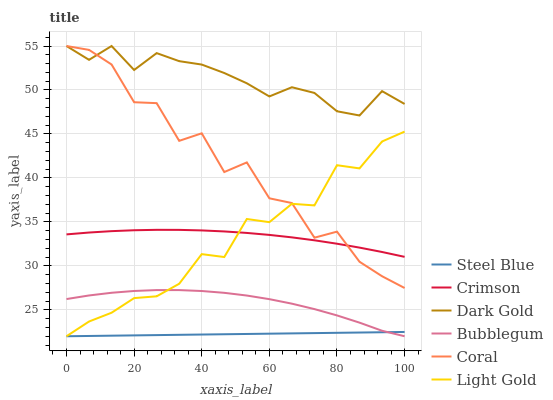Does Coral have the minimum area under the curve?
Answer yes or no. No. Does Coral have the maximum area under the curve?
Answer yes or no. No. Is Coral the smoothest?
Answer yes or no. No. Is Steel Blue the roughest?
Answer yes or no. No. Does Coral have the lowest value?
Answer yes or no. No. Does Steel Blue have the highest value?
Answer yes or no. No. Is Steel Blue less than Crimson?
Answer yes or no. Yes. Is Dark Gold greater than Crimson?
Answer yes or no. Yes. Does Steel Blue intersect Crimson?
Answer yes or no. No. 